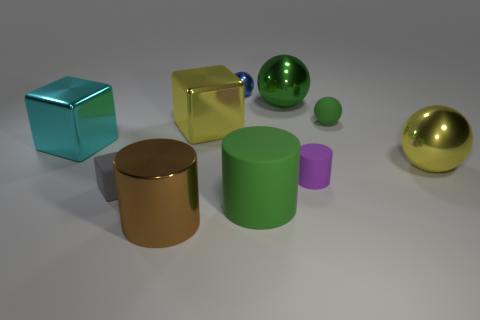What number of things are either green metallic things or big things in front of the green rubber sphere?
Your response must be concise. 6. There is a metal object that is left of the big brown shiny thing; is it the same shape as the tiny gray matte thing?
Give a very brief answer. Yes. How many shiny things are right of the big green object that is behind the small sphere to the right of the blue shiny object?
Ensure brevity in your answer.  1. What number of objects are green cylinders or small purple objects?
Your answer should be very brief. 2. There is a tiny purple rubber thing; is its shape the same as the green object in front of the small green matte object?
Keep it short and to the point. Yes. The large green object that is behind the big yellow block has what shape?
Your answer should be compact. Sphere. Is the shape of the purple rubber thing the same as the tiny gray rubber object?
Offer a very short reply. No. What size is the yellow thing that is the same shape as the tiny green rubber thing?
Your answer should be compact. Large. There is a purple rubber cylinder that is behind the gray rubber cube; does it have the same size as the shiny cylinder?
Keep it short and to the point. No. There is a thing that is left of the big green matte cylinder and in front of the small cube; what size is it?
Provide a succinct answer. Large. 